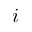Convert formula to latex. <formula><loc_0><loc_0><loc_500><loc_500>i</formula> 